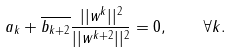<formula> <loc_0><loc_0><loc_500><loc_500>a _ { k } + \overline { b _ { k + 2 } } \frac { | | w ^ { k } | | ^ { 2 } } { | | w ^ { k + 2 } | | ^ { 2 } } = 0 , \quad \forall k .</formula> 